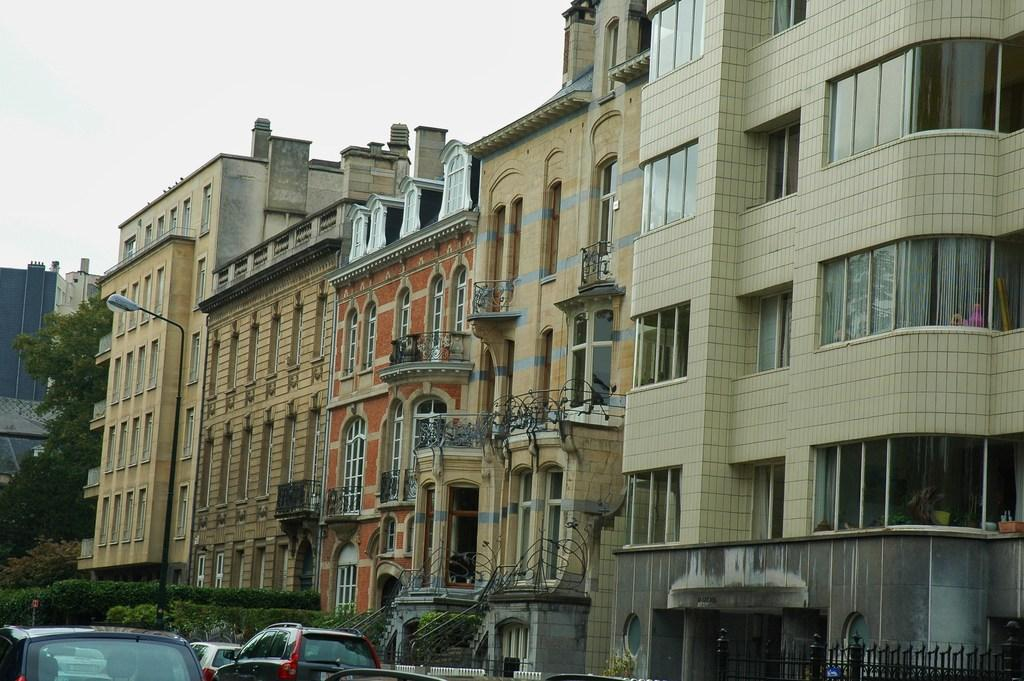What can be seen on the left side of the image? There are cars, plants, and trees on the left side of the image. What is located in the center of the image? There are buildings and a street light in the center of the image. What is visible at the top of the image? The sky is visible at the top of the image. What is the condition of the sky in the image? The sky is cloudy in the image. What type of tin can be seen in the image? There is no tin present in the image. How does the thread connect the buildings in the image? There is no thread connecting the buildings in the image; it is a photograph and not a drawing or illustration. 